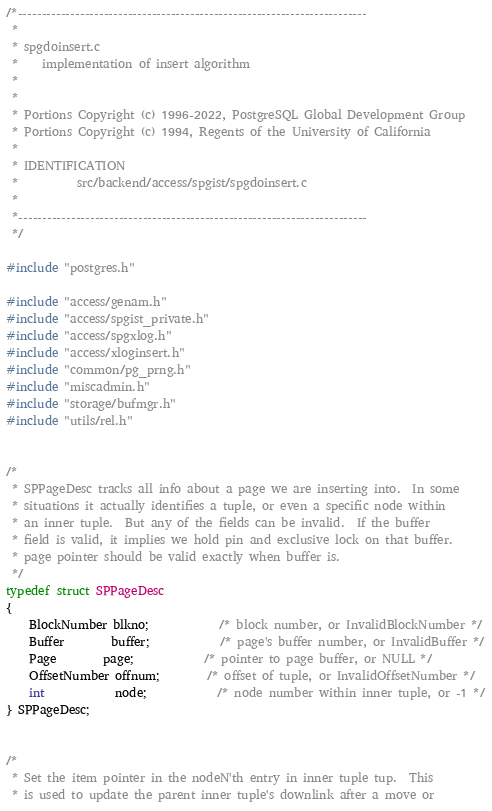Convert code to text. <code><loc_0><loc_0><loc_500><loc_500><_C_>/*-------------------------------------------------------------------------
 *
 * spgdoinsert.c
 *	  implementation of insert algorithm
 *
 *
 * Portions Copyright (c) 1996-2022, PostgreSQL Global Development Group
 * Portions Copyright (c) 1994, Regents of the University of California
 *
 * IDENTIFICATION
 *			src/backend/access/spgist/spgdoinsert.c
 *
 *-------------------------------------------------------------------------
 */

#include "postgres.h"

#include "access/genam.h"
#include "access/spgist_private.h"
#include "access/spgxlog.h"
#include "access/xloginsert.h"
#include "common/pg_prng.h"
#include "miscadmin.h"
#include "storage/bufmgr.h"
#include "utils/rel.h"


/*
 * SPPageDesc tracks all info about a page we are inserting into.  In some
 * situations it actually identifies a tuple, or even a specific node within
 * an inner tuple.  But any of the fields can be invalid.  If the buffer
 * field is valid, it implies we hold pin and exclusive lock on that buffer.
 * page pointer should be valid exactly when buffer is.
 */
typedef struct SPPageDesc
{
	BlockNumber blkno;			/* block number, or InvalidBlockNumber */
	Buffer		buffer;			/* page's buffer number, or InvalidBuffer */
	Page		page;			/* pointer to page buffer, or NULL */
	OffsetNumber offnum;		/* offset of tuple, or InvalidOffsetNumber */
	int			node;			/* node number within inner tuple, or -1 */
} SPPageDesc;


/*
 * Set the item pointer in the nodeN'th entry in inner tuple tup.  This
 * is used to update the parent inner tuple's downlink after a move or</code> 